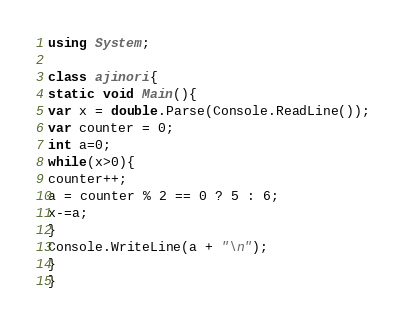<code> <loc_0><loc_0><loc_500><loc_500><_C#_>using System;

class ajinori{
static void Main(){
var x = double.Parse(Console.ReadLine());
var counter = 0;
int a=0;
while(x>0){
counter++;
a = counter % 2 == 0 ? 5 : 6;
x-=a;
}
Console.WriteLine(a + "\n");
}
}</code> 